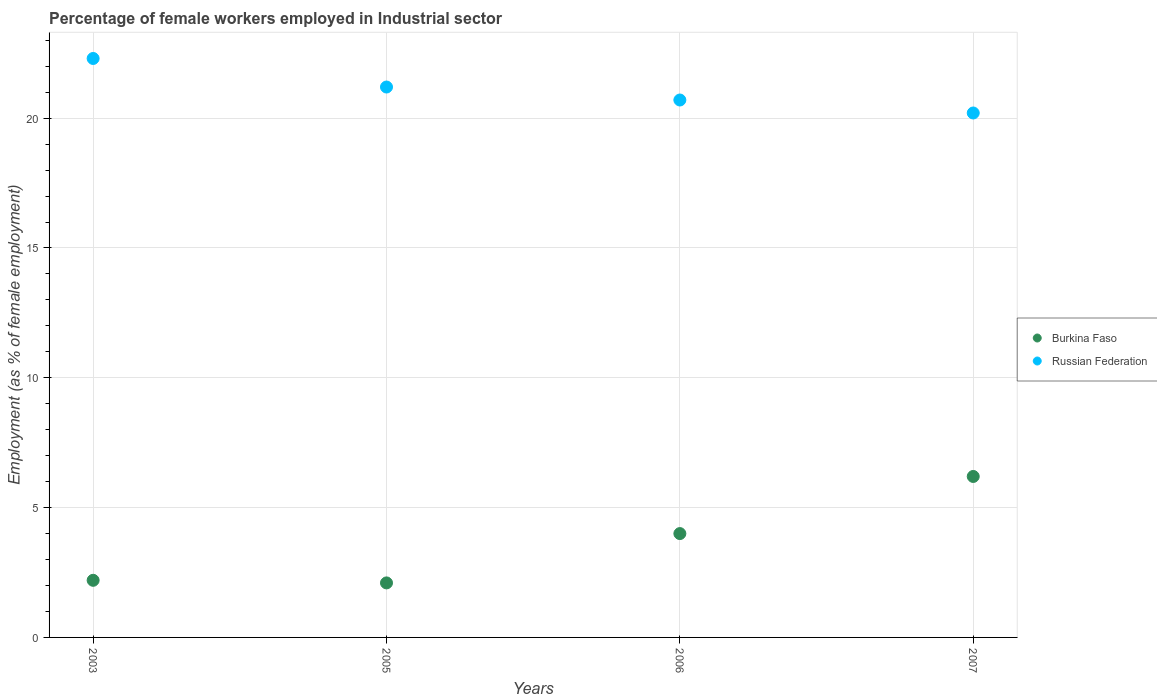What is the percentage of females employed in Industrial sector in Russian Federation in 2003?
Provide a succinct answer. 22.3. Across all years, what is the maximum percentage of females employed in Industrial sector in Burkina Faso?
Your answer should be very brief. 6.2. Across all years, what is the minimum percentage of females employed in Industrial sector in Burkina Faso?
Your answer should be very brief. 2.1. In which year was the percentage of females employed in Industrial sector in Burkina Faso minimum?
Your response must be concise. 2005. What is the total percentage of females employed in Industrial sector in Burkina Faso in the graph?
Keep it short and to the point. 14.5. What is the difference between the percentage of females employed in Industrial sector in Burkina Faso in 2005 and that in 2006?
Offer a very short reply. -1.9. What is the difference between the percentage of females employed in Industrial sector in Russian Federation in 2006 and the percentage of females employed in Industrial sector in Burkina Faso in 2003?
Give a very brief answer. 18.5. What is the average percentage of females employed in Industrial sector in Burkina Faso per year?
Provide a short and direct response. 3.62. In the year 2006, what is the difference between the percentage of females employed in Industrial sector in Burkina Faso and percentage of females employed in Industrial sector in Russian Federation?
Your response must be concise. -16.7. What is the ratio of the percentage of females employed in Industrial sector in Burkina Faso in 2003 to that in 2007?
Give a very brief answer. 0.35. Is the difference between the percentage of females employed in Industrial sector in Burkina Faso in 2003 and 2005 greater than the difference between the percentage of females employed in Industrial sector in Russian Federation in 2003 and 2005?
Make the answer very short. No. What is the difference between the highest and the second highest percentage of females employed in Industrial sector in Russian Federation?
Provide a succinct answer. 1.1. What is the difference between the highest and the lowest percentage of females employed in Industrial sector in Burkina Faso?
Keep it short and to the point. 4.1. Is the sum of the percentage of females employed in Industrial sector in Russian Federation in 2006 and 2007 greater than the maximum percentage of females employed in Industrial sector in Burkina Faso across all years?
Provide a succinct answer. Yes. Is the percentage of females employed in Industrial sector in Burkina Faso strictly less than the percentage of females employed in Industrial sector in Russian Federation over the years?
Your response must be concise. Yes. How many years are there in the graph?
Make the answer very short. 4. Are the values on the major ticks of Y-axis written in scientific E-notation?
Your answer should be compact. No. Does the graph contain any zero values?
Give a very brief answer. No. Does the graph contain grids?
Provide a succinct answer. Yes. Where does the legend appear in the graph?
Keep it short and to the point. Center right. How many legend labels are there?
Make the answer very short. 2. What is the title of the graph?
Ensure brevity in your answer.  Percentage of female workers employed in Industrial sector. Does "Ghana" appear as one of the legend labels in the graph?
Make the answer very short. No. What is the label or title of the Y-axis?
Provide a succinct answer. Employment (as % of female employment). What is the Employment (as % of female employment) in Burkina Faso in 2003?
Provide a succinct answer. 2.2. What is the Employment (as % of female employment) in Russian Federation in 2003?
Give a very brief answer. 22.3. What is the Employment (as % of female employment) of Burkina Faso in 2005?
Ensure brevity in your answer.  2.1. What is the Employment (as % of female employment) of Russian Federation in 2005?
Make the answer very short. 21.2. What is the Employment (as % of female employment) of Russian Federation in 2006?
Keep it short and to the point. 20.7. What is the Employment (as % of female employment) of Burkina Faso in 2007?
Provide a succinct answer. 6.2. What is the Employment (as % of female employment) in Russian Federation in 2007?
Make the answer very short. 20.2. Across all years, what is the maximum Employment (as % of female employment) of Burkina Faso?
Provide a short and direct response. 6.2. Across all years, what is the maximum Employment (as % of female employment) in Russian Federation?
Offer a very short reply. 22.3. Across all years, what is the minimum Employment (as % of female employment) in Burkina Faso?
Make the answer very short. 2.1. Across all years, what is the minimum Employment (as % of female employment) in Russian Federation?
Your answer should be very brief. 20.2. What is the total Employment (as % of female employment) of Burkina Faso in the graph?
Offer a very short reply. 14.5. What is the total Employment (as % of female employment) in Russian Federation in the graph?
Ensure brevity in your answer.  84.4. What is the difference between the Employment (as % of female employment) of Russian Federation in 2003 and that in 2005?
Make the answer very short. 1.1. What is the difference between the Employment (as % of female employment) in Burkina Faso in 2003 and that in 2006?
Your response must be concise. -1.8. What is the difference between the Employment (as % of female employment) in Burkina Faso in 2003 and that in 2007?
Give a very brief answer. -4. What is the difference between the Employment (as % of female employment) of Russian Federation in 2003 and that in 2007?
Provide a succinct answer. 2.1. What is the difference between the Employment (as % of female employment) in Russian Federation in 2005 and that in 2006?
Offer a terse response. 0.5. What is the difference between the Employment (as % of female employment) of Burkina Faso in 2006 and that in 2007?
Give a very brief answer. -2.2. What is the difference between the Employment (as % of female employment) in Burkina Faso in 2003 and the Employment (as % of female employment) in Russian Federation in 2005?
Provide a short and direct response. -19. What is the difference between the Employment (as % of female employment) in Burkina Faso in 2003 and the Employment (as % of female employment) in Russian Federation in 2006?
Your response must be concise. -18.5. What is the difference between the Employment (as % of female employment) in Burkina Faso in 2003 and the Employment (as % of female employment) in Russian Federation in 2007?
Provide a succinct answer. -18. What is the difference between the Employment (as % of female employment) in Burkina Faso in 2005 and the Employment (as % of female employment) in Russian Federation in 2006?
Give a very brief answer. -18.6. What is the difference between the Employment (as % of female employment) of Burkina Faso in 2005 and the Employment (as % of female employment) of Russian Federation in 2007?
Your answer should be compact. -18.1. What is the difference between the Employment (as % of female employment) of Burkina Faso in 2006 and the Employment (as % of female employment) of Russian Federation in 2007?
Provide a succinct answer. -16.2. What is the average Employment (as % of female employment) of Burkina Faso per year?
Your response must be concise. 3.62. What is the average Employment (as % of female employment) of Russian Federation per year?
Your response must be concise. 21.1. In the year 2003, what is the difference between the Employment (as % of female employment) of Burkina Faso and Employment (as % of female employment) of Russian Federation?
Offer a very short reply. -20.1. In the year 2005, what is the difference between the Employment (as % of female employment) of Burkina Faso and Employment (as % of female employment) of Russian Federation?
Offer a terse response. -19.1. In the year 2006, what is the difference between the Employment (as % of female employment) in Burkina Faso and Employment (as % of female employment) in Russian Federation?
Keep it short and to the point. -16.7. In the year 2007, what is the difference between the Employment (as % of female employment) of Burkina Faso and Employment (as % of female employment) of Russian Federation?
Ensure brevity in your answer.  -14. What is the ratio of the Employment (as % of female employment) of Burkina Faso in 2003 to that in 2005?
Make the answer very short. 1.05. What is the ratio of the Employment (as % of female employment) in Russian Federation in 2003 to that in 2005?
Your response must be concise. 1.05. What is the ratio of the Employment (as % of female employment) in Burkina Faso in 2003 to that in 2006?
Provide a short and direct response. 0.55. What is the ratio of the Employment (as % of female employment) of Russian Federation in 2003 to that in 2006?
Provide a succinct answer. 1.08. What is the ratio of the Employment (as % of female employment) of Burkina Faso in 2003 to that in 2007?
Your answer should be very brief. 0.35. What is the ratio of the Employment (as % of female employment) in Russian Federation in 2003 to that in 2007?
Make the answer very short. 1.1. What is the ratio of the Employment (as % of female employment) of Burkina Faso in 2005 to that in 2006?
Provide a succinct answer. 0.53. What is the ratio of the Employment (as % of female employment) in Russian Federation in 2005 to that in 2006?
Provide a short and direct response. 1.02. What is the ratio of the Employment (as % of female employment) in Burkina Faso in 2005 to that in 2007?
Your response must be concise. 0.34. What is the ratio of the Employment (as % of female employment) of Russian Federation in 2005 to that in 2007?
Offer a very short reply. 1.05. What is the ratio of the Employment (as % of female employment) in Burkina Faso in 2006 to that in 2007?
Offer a terse response. 0.65. What is the ratio of the Employment (as % of female employment) in Russian Federation in 2006 to that in 2007?
Make the answer very short. 1.02. What is the difference between the highest and the second highest Employment (as % of female employment) of Burkina Faso?
Offer a very short reply. 2.2. What is the difference between the highest and the lowest Employment (as % of female employment) of Burkina Faso?
Ensure brevity in your answer.  4.1. What is the difference between the highest and the lowest Employment (as % of female employment) in Russian Federation?
Offer a very short reply. 2.1. 